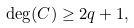<formula> <loc_0><loc_0><loc_500><loc_500>\deg ( C ) \geq 2 q + 1 ,</formula> 